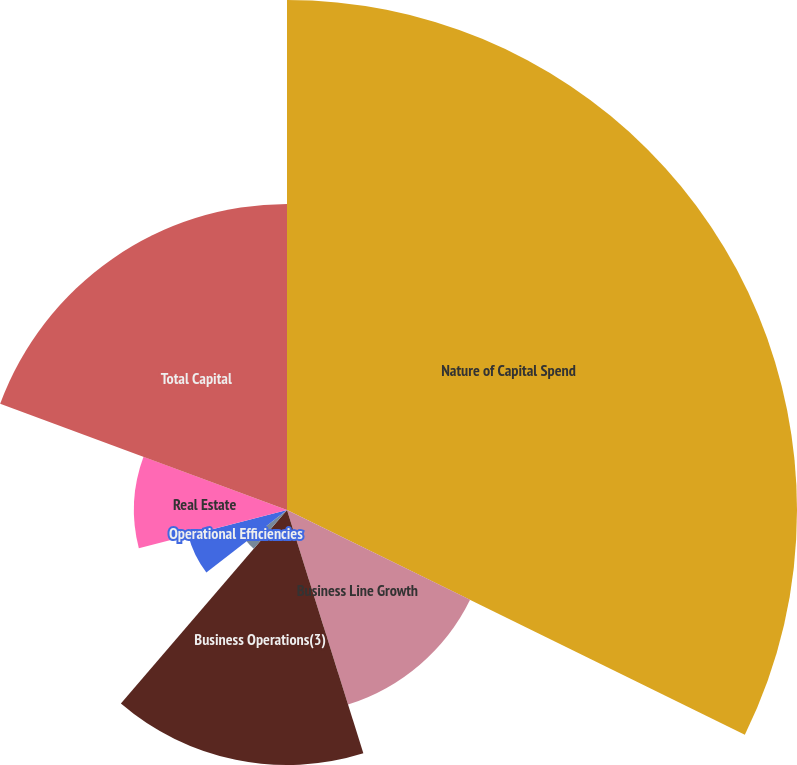<chart> <loc_0><loc_0><loc_500><loc_500><pie_chart><fcel>Nature of Capital Spend<fcel>Business Line Growth<fcel>Business Operations(3)<fcel>Product Development<fcel>Product Improvement<fcel>Operational Efficiencies<fcel>Real Estate<fcel>Total Capital<nl><fcel>32.26%<fcel>12.9%<fcel>16.13%<fcel>0.0%<fcel>3.23%<fcel>6.45%<fcel>9.68%<fcel>19.35%<nl></chart> 